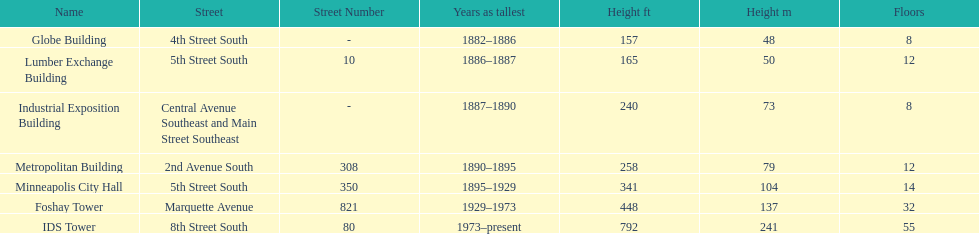Name the tallest building. IDS Tower. 